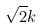<formula> <loc_0><loc_0><loc_500><loc_500>\sqrt { 2 } k</formula> 